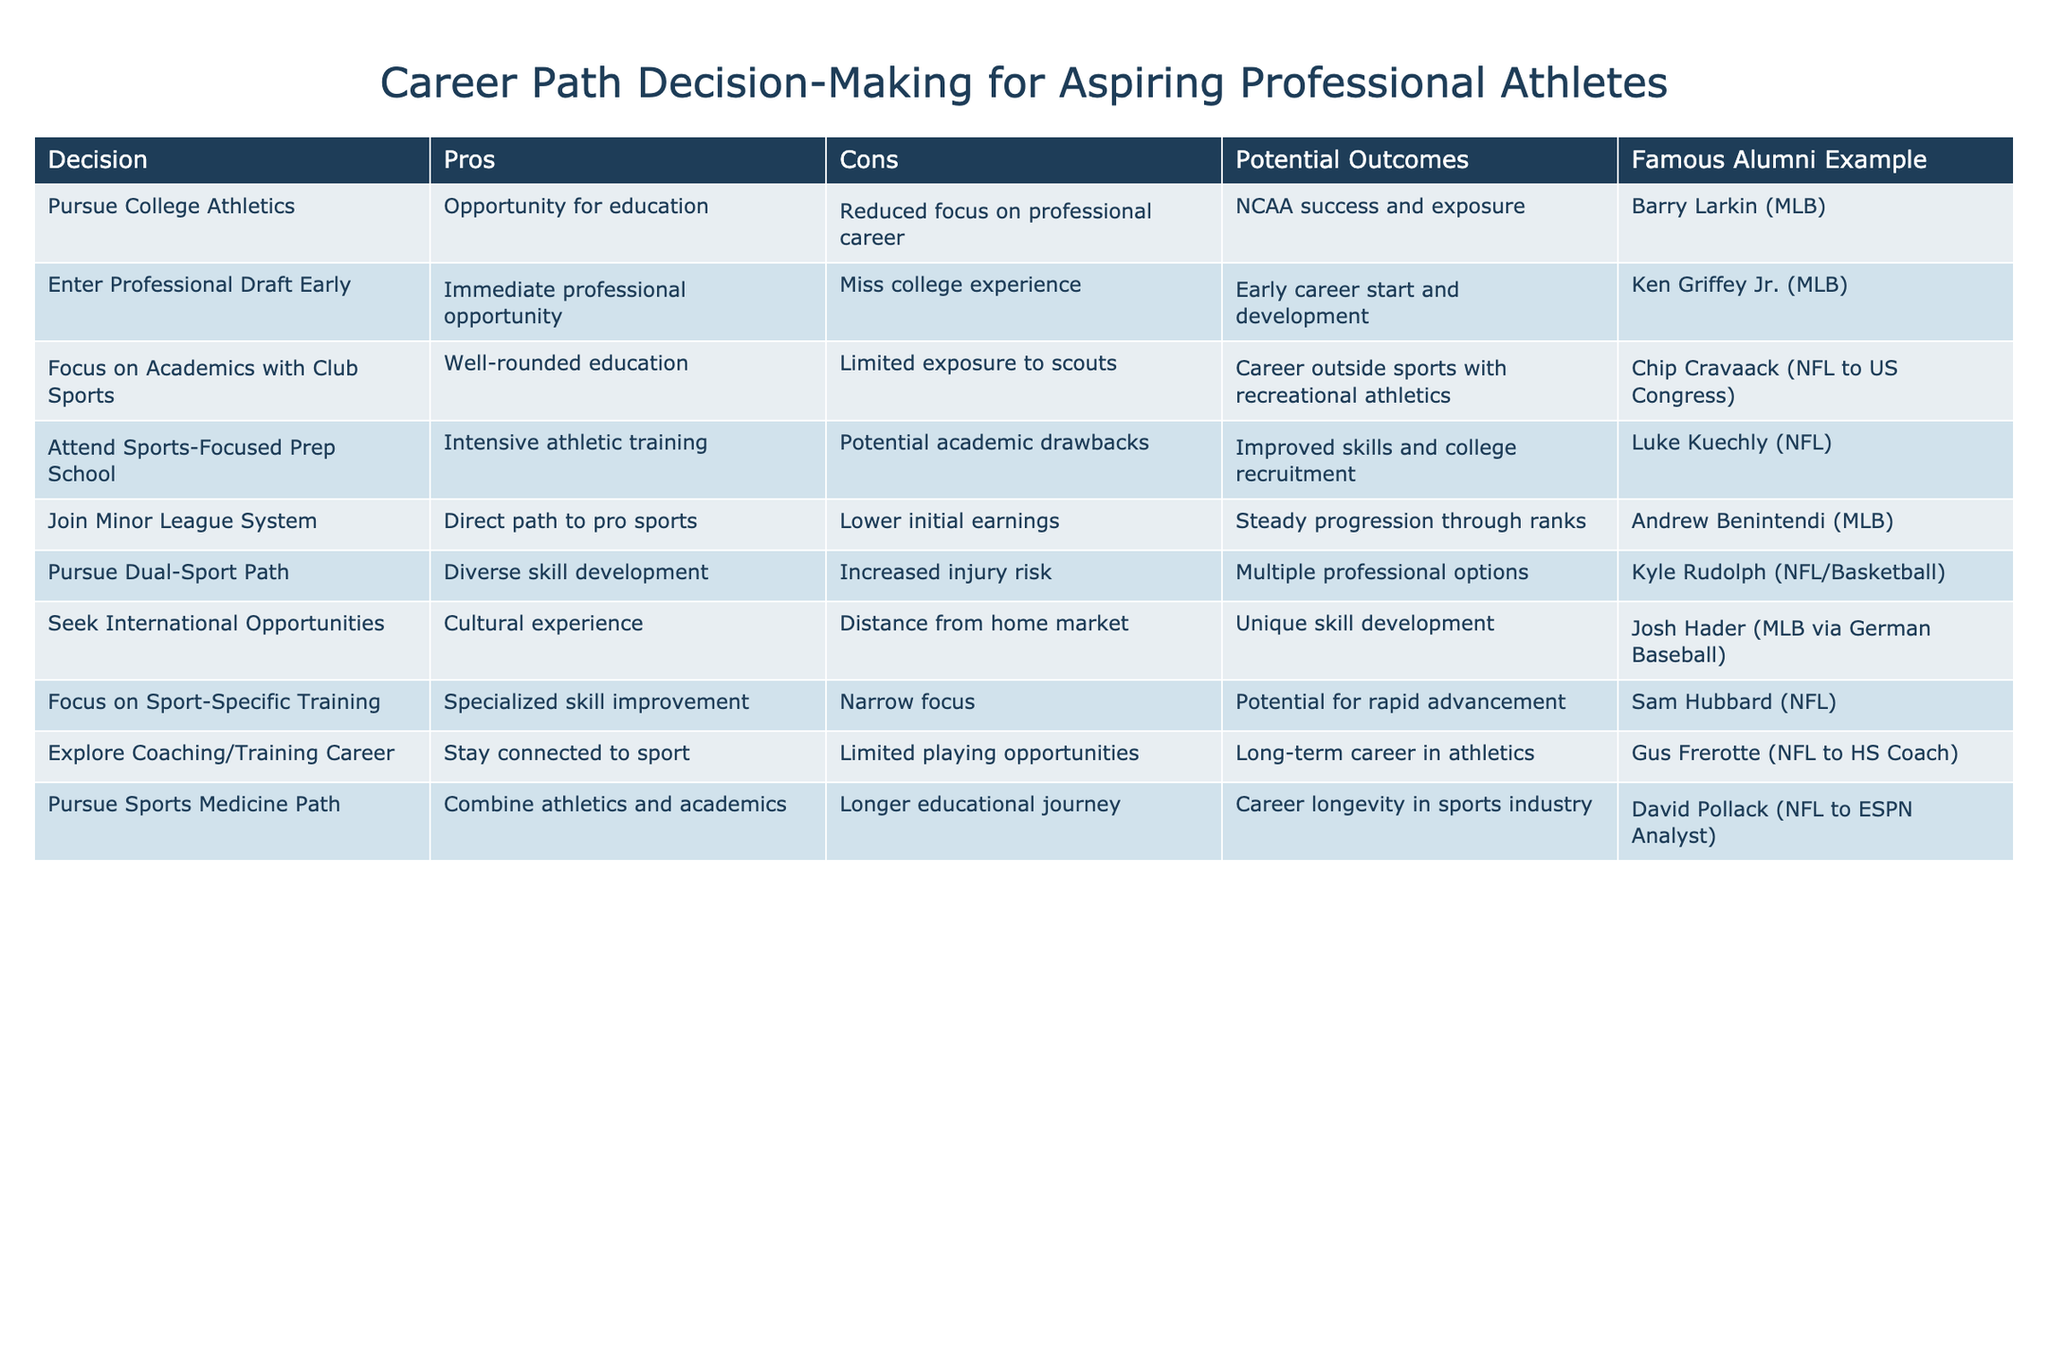What is the potential outcome of pursuing college athletics? According to the table, the potential outcome of pursuing college athletics is "NCAA success and exposure." This information can be found directly in the corresponding row for "Pursue College Athletics."
Answer: NCAA success and exposure Which option includes the famous alumni example of Barry Larkin? The famous alumni example of Barry Larkin corresponds to the path of "Pursue College Athletics." This can be verified by locating Barry Larkin in the Famous Alumni Example column and checking the associated decision.
Answer: Pursue College Athletics What are the cons of entering the professional draft early? The cons of entering the professional draft early, as stated in the table, are "Miss college experience." This information is easily found in the cons column for the "Enter Professional Draft Early" row.
Answer: Miss college experience Which decision has the lowest initial earnings? The decision with the lowest initial earnings is "Join Minor League System." This conclusion can be drawn from reviewing the cons column, where it states "Lower initial earnings" for that specific option.
Answer: Join Minor League System Is it true that attending a sports-focused prep school can lead to improved skills and college recruitment? Yes, it is true. The table indicates that one of the potential outcomes of attending a sports-focused prep school is "Improved skills and college recruitment." Therefore, the statement is confirmed.
Answer: Yes What is the difference in exposure between focusing on academics with club sports and pursuing college athletics? Focusing on academics with club sports has "Limited exposure to scouts," while pursuing college athletics offers "NCAA success and exposure." The difference is the focus; one reduces visibility to scouts, while the other enhances it through NCAA participation.
Answer: Limited exposure vs. NCAA success Which option offers an opportunity for a unique skill development experience? The option that offers a unique skill development experience is "Seek International Opportunities." This information can be found in the potential outcomes column, where it states "Unique skill development."
Answer: Seek International Opportunities How many potential outcomes are listed for the "Pursue Dual-Sport Path"? According to the table, the potential outcomes listed for "Pursue Dual-Sport Path" is "Multiple professional options." There is only one outcome mentioned for this decision in the associated row.
Answer: 1 potential outcome What is the common theme among decisions that lead to a stay-connected career in athletics? The common theme among the decisions "Explore Coaching/Training Career" and "Pursue Sports Medicine Path" is that they both provide avenues for a long-term connection to athletics, as each has outcomes related to remaining in the sports industry, despite not being a professional athlete.
Answer: Long-term connection to athletics 